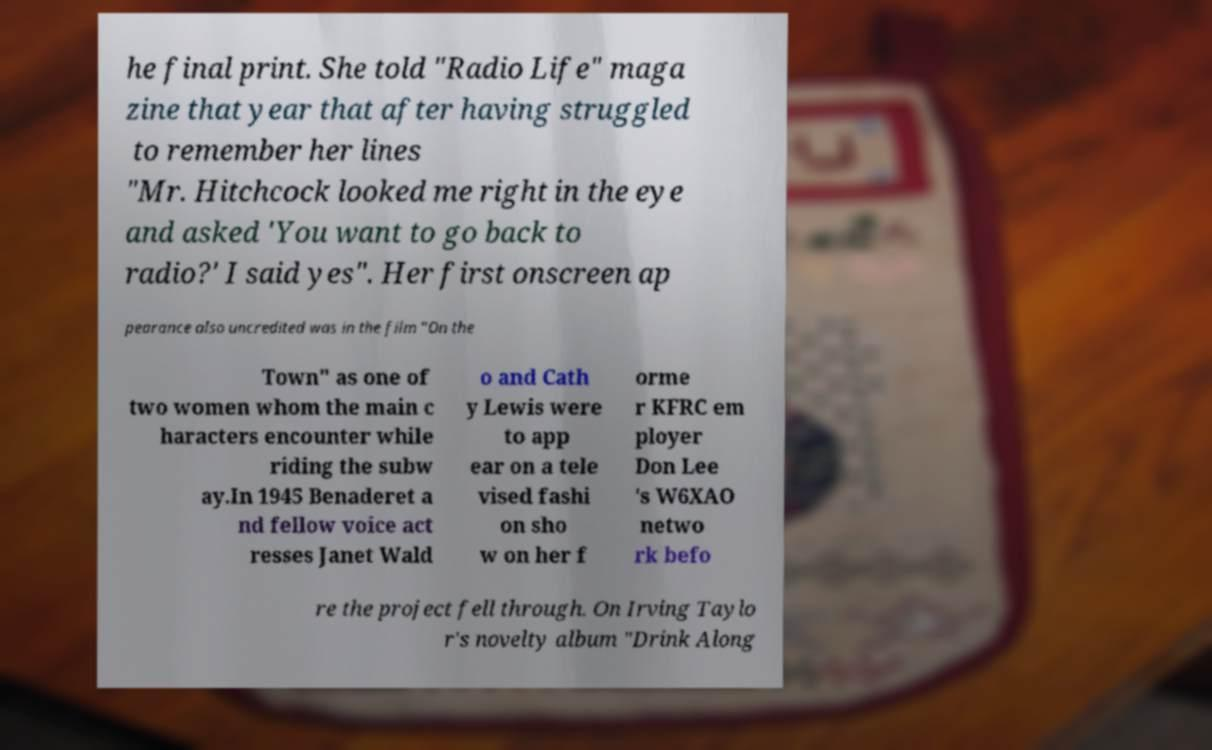I need the written content from this picture converted into text. Can you do that? he final print. She told "Radio Life" maga zine that year that after having struggled to remember her lines "Mr. Hitchcock looked me right in the eye and asked 'You want to go back to radio?' I said yes". Her first onscreen ap pearance also uncredited was in the film "On the Town" as one of two women whom the main c haracters encounter while riding the subw ay.In 1945 Benaderet a nd fellow voice act resses Janet Wald o and Cath y Lewis were to app ear on a tele vised fashi on sho w on her f orme r KFRC em ployer Don Lee 's W6XAO netwo rk befo re the project fell through. On Irving Taylo r's novelty album "Drink Along 